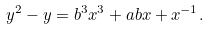<formula> <loc_0><loc_0><loc_500><loc_500>y ^ { 2 } - y = b ^ { 3 } x ^ { 3 } + a b x + x ^ { - 1 } .</formula> 